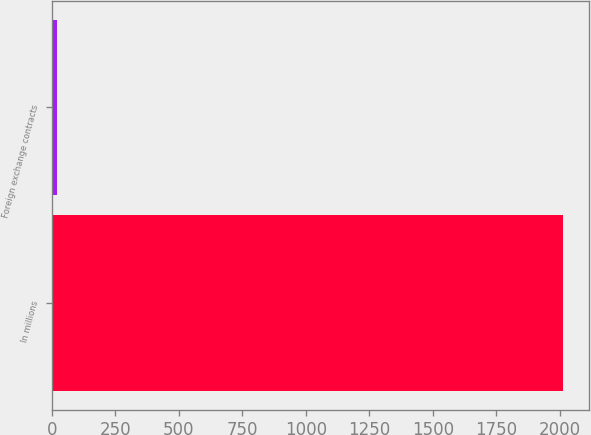<chart> <loc_0><loc_0><loc_500><loc_500><bar_chart><fcel>In millions<fcel>Foreign exchange contracts<nl><fcel>2013<fcel>21<nl></chart> 